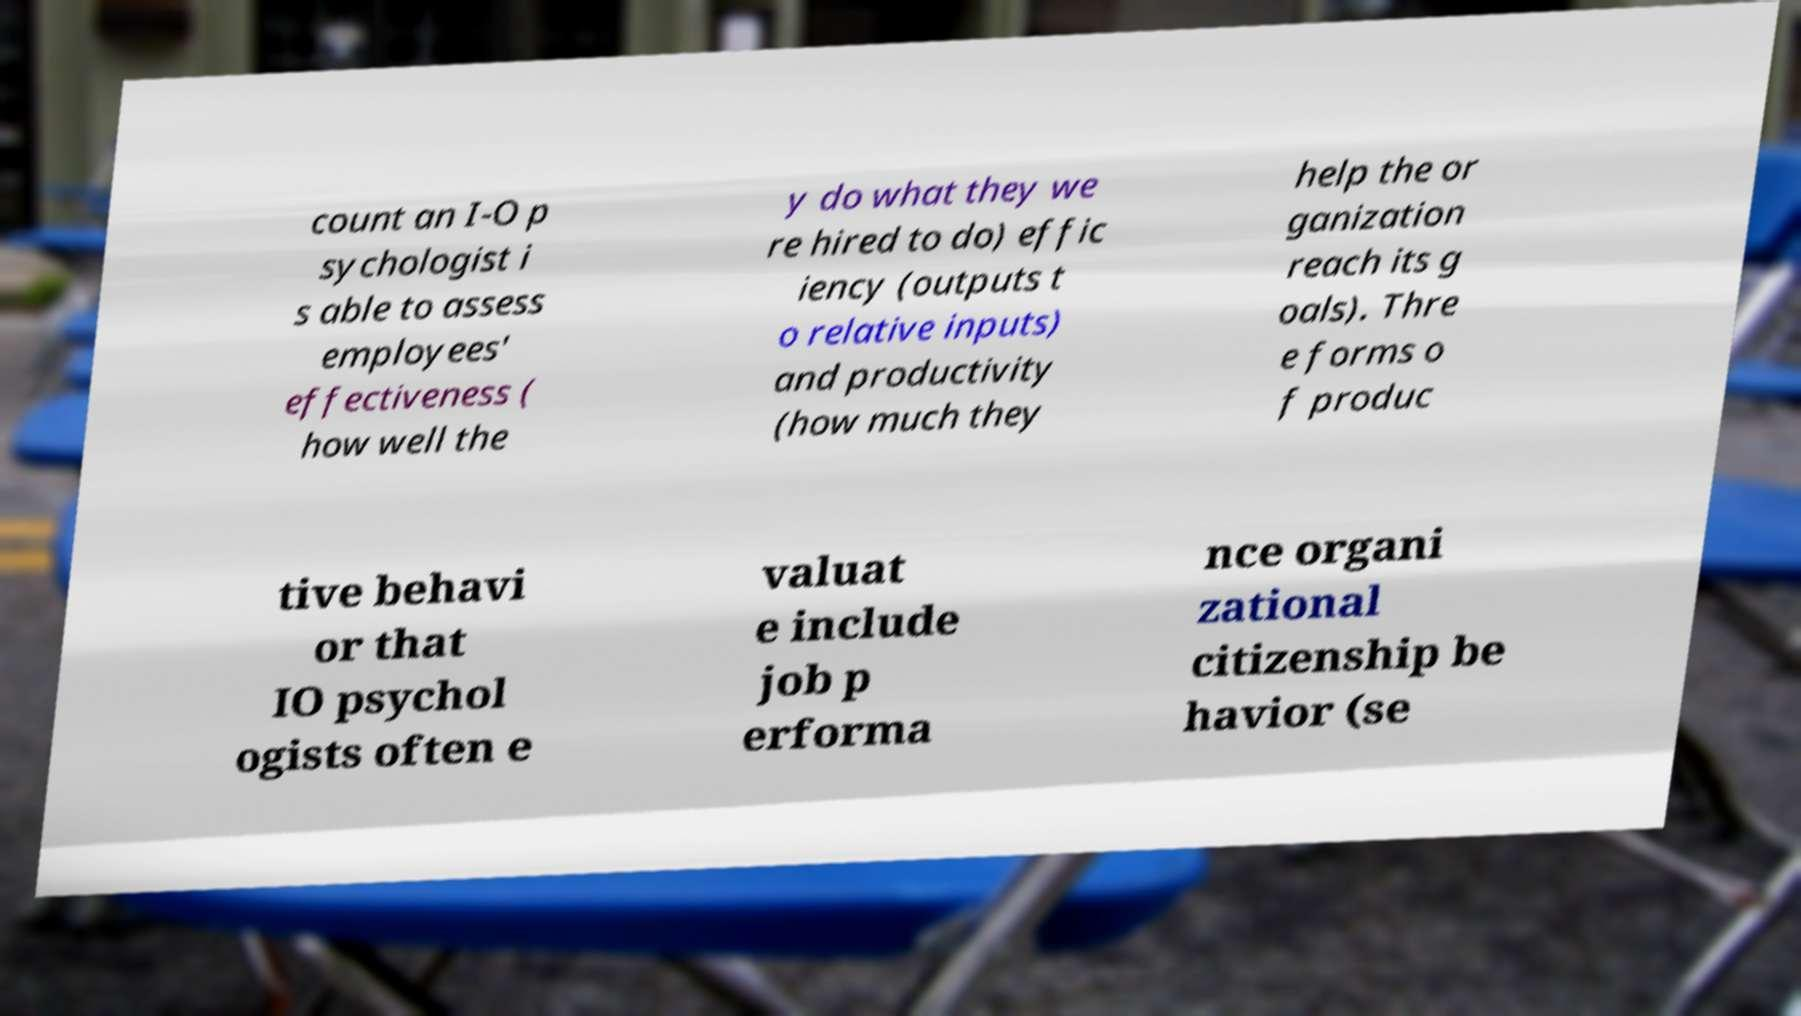There's text embedded in this image that I need extracted. Can you transcribe it verbatim? count an I-O p sychologist i s able to assess employees' effectiveness ( how well the y do what they we re hired to do) effic iency (outputs t o relative inputs) and productivity (how much they help the or ganization reach its g oals). Thre e forms o f produc tive behavi or that IO psychol ogists often e valuat e include job p erforma nce organi zational citizenship be havior (se 